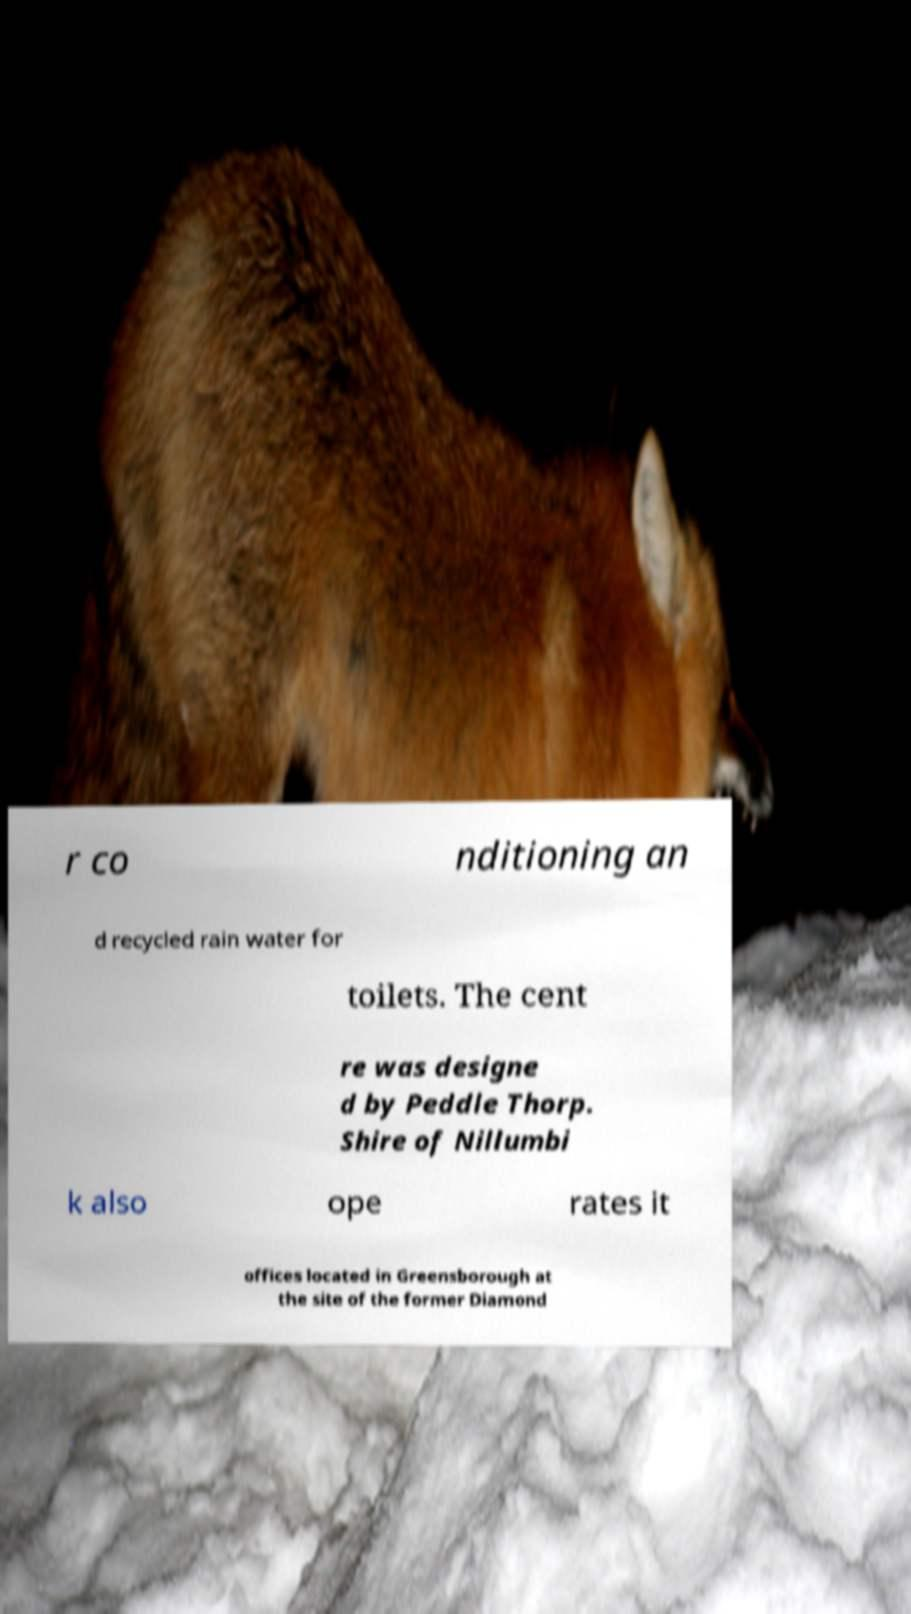I need the written content from this picture converted into text. Can you do that? r co nditioning an d recycled rain water for toilets. The cent re was designe d by Peddle Thorp. Shire of Nillumbi k also ope rates it offices located in Greensborough at the site of the former Diamond 